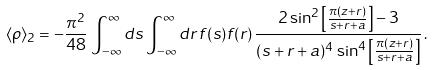<formula> <loc_0><loc_0><loc_500><loc_500>\langle \rho \rangle _ { 2 } = - \frac { \pi ^ { 2 } } { 4 8 } \, \int _ { - \infty } ^ { \infty } d s \int _ { - \infty } ^ { \infty } d r \, f ( s ) f ( r ) \, \frac { 2 \sin ^ { 2 } \left [ \frac { \pi ( z + r ) } { s + r + a } \right ] - 3 } { ( s + r + a ) ^ { 4 } \, \sin ^ { 4 } \left [ \frac { \pi ( z + r ) } { s + r + a } \right ] } \, .</formula> 